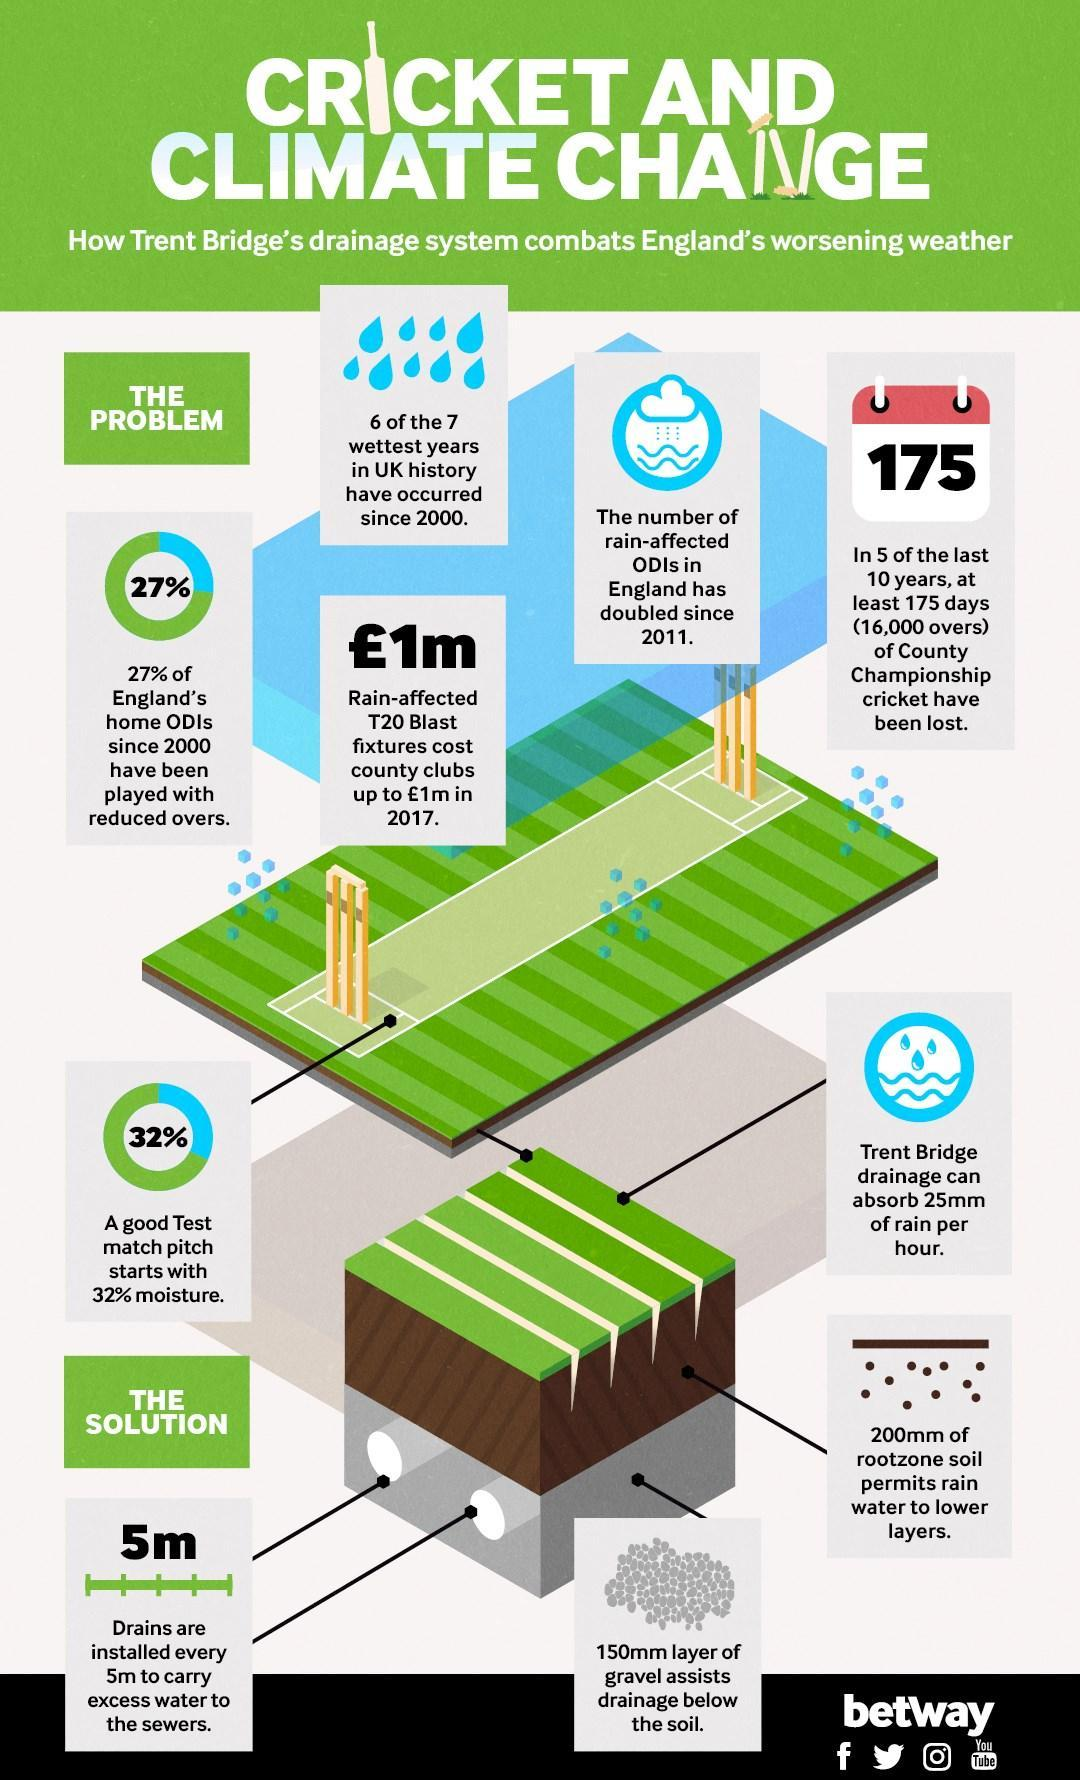What assists drainage below the soil
Answer the question with a short phrase. 150mm layer of gravel What % of ODis since 2000 have been played with the correct overs 73 What is the area between the wickets called pitch 